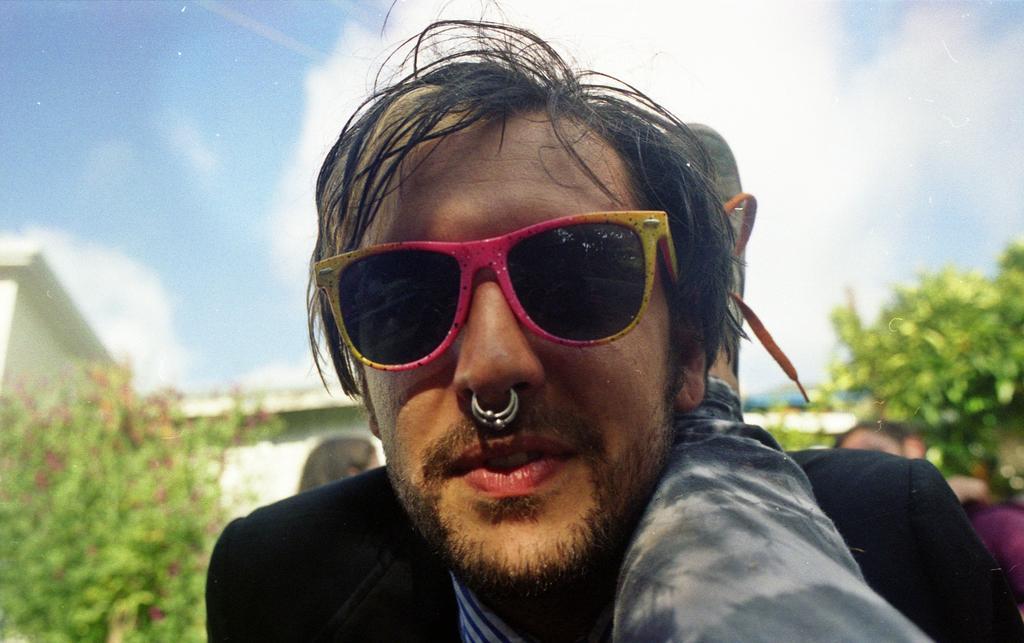In one or two sentences, can you explain what this image depicts? In this image we can see a person wearing glasses. In the background there are trees and a building. We can see people. There is sky. 